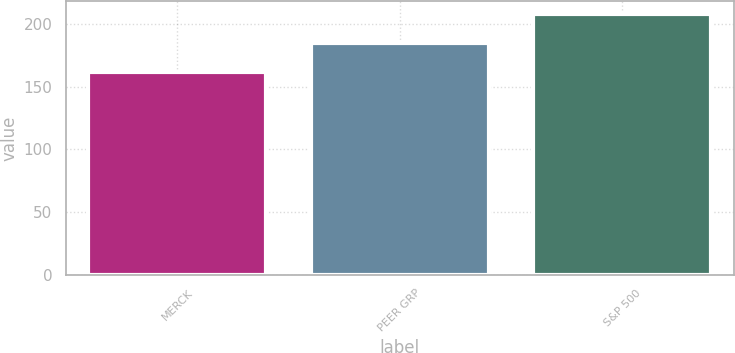Convert chart. <chart><loc_0><loc_0><loc_500><loc_500><bar_chart><fcel>MERCK<fcel>PEER GRP<fcel>S&P 500<nl><fcel>161.8<fcel>184.7<fcel>208.1<nl></chart> 